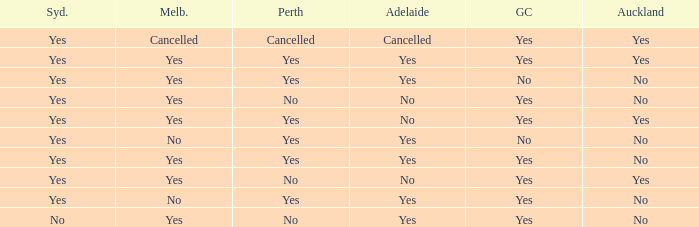What is The Melbourne with a No- Gold Coast Yes, No. 